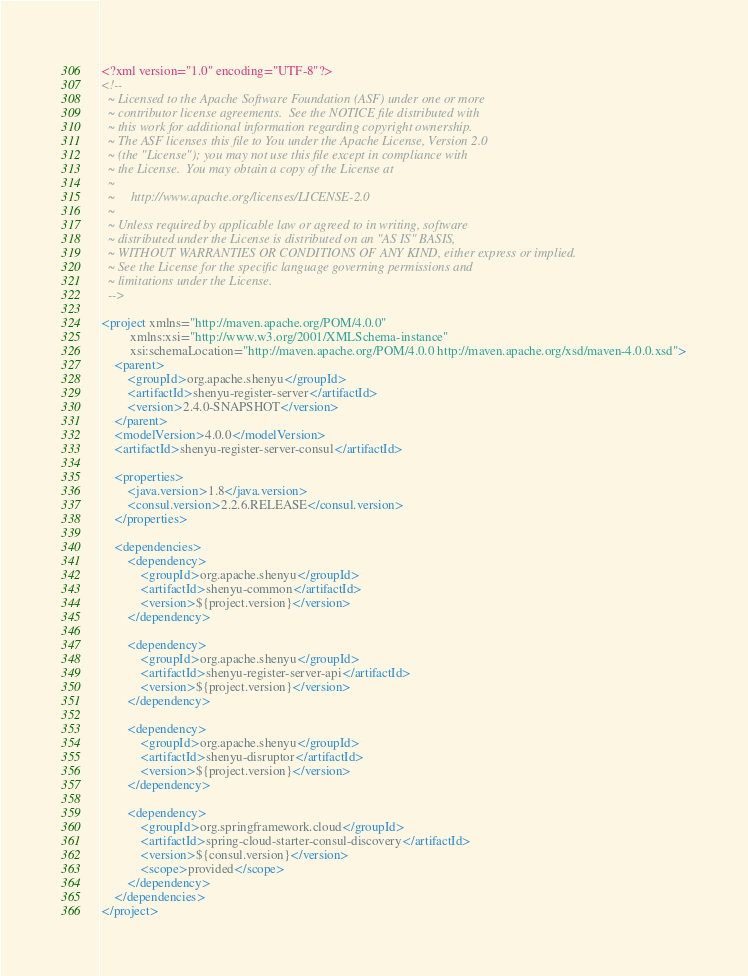Convert code to text. <code><loc_0><loc_0><loc_500><loc_500><_XML_><?xml version="1.0" encoding="UTF-8"?>
<!--
  ~ Licensed to the Apache Software Foundation (ASF) under one or more
  ~ contributor license agreements.  See the NOTICE file distributed with
  ~ this work for additional information regarding copyright ownership.
  ~ The ASF licenses this file to You under the Apache License, Version 2.0
  ~ (the "License"); you may not use this file except in compliance with
  ~ the License.  You may obtain a copy of the License at
  ~
  ~     http://www.apache.org/licenses/LICENSE-2.0
  ~
  ~ Unless required by applicable law or agreed to in writing, software
  ~ distributed under the License is distributed on an "AS IS" BASIS,
  ~ WITHOUT WARRANTIES OR CONDITIONS OF ANY KIND, either express or implied.
  ~ See the License for the specific language governing permissions and
  ~ limitations under the License.
  -->

<project xmlns="http://maven.apache.org/POM/4.0.0"
         xmlns:xsi="http://www.w3.org/2001/XMLSchema-instance"
         xsi:schemaLocation="http://maven.apache.org/POM/4.0.0 http://maven.apache.org/xsd/maven-4.0.0.xsd">
    <parent>
        <groupId>org.apache.shenyu</groupId>
        <artifactId>shenyu-register-server</artifactId>
        <version>2.4.0-SNAPSHOT</version>
    </parent>
    <modelVersion>4.0.0</modelVersion>
    <artifactId>shenyu-register-server-consul</artifactId>

    <properties>
        <java.version>1.8</java.version>
        <consul.version>2.2.6.RELEASE</consul.version>
    </properties>

    <dependencies>
        <dependency>
            <groupId>org.apache.shenyu</groupId>
            <artifactId>shenyu-common</artifactId>
            <version>${project.version}</version>
        </dependency>

        <dependency>
            <groupId>org.apache.shenyu</groupId>
            <artifactId>shenyu-register-server-api</artifactId>
            <version>${project.version}</version>
        </dependency>

        <dependency>
            <groupId>org.apache.shenyu</groupId>
            <artifactId>shenyu-disruptor</artifactId>
            <version>${project.version}</version>
        </dependency>

        <dependency>
            <groupId>org.springframework.cloud</groupId>
            <artifactId>spring-cloud-starter-consul-discovery</artifactId>
            <version>${consul.version}</version>
            <scope>provided</scope>
        </dependency>
    </dependencies>
</project></code> 